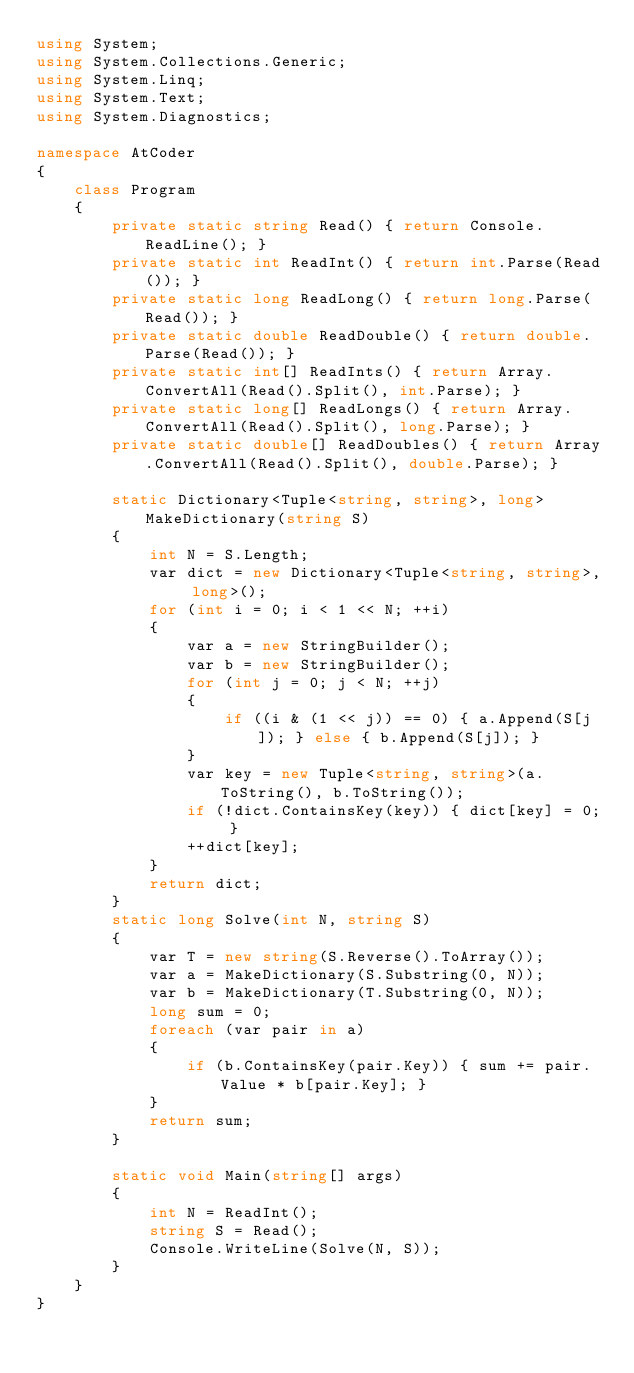Convert code to text. <code><loc_0><loc_0><loc_500><loc_500><_C#_>using System;
using System.Collections.Generic;
using System.Linq;
using System.Text;
using System.Diagnostics;

namespace AtCoder
{
    class Program
    {
        private static string Read() { return Console.ReadLine(); }
        private static int ReadInt() { return int.Parse(Read()); }
        private static long ReadLong() { return long.Parse(Read()); }
        private static double ReadDouble() { return double.Parse(Read()); }
        private static int[] ReadInts() { return Array.ConvertAll(Read().Split(), int.Parse); }
        private static long[] ReadLongs() { return Array.ConvertAll(Read().Split(), long.Parse); }
        private static double[] ReadDoubles() { return Array.ConvertAll(Read().Split(), double.Parse); }

        static Dictionary<Tuple<string, string>, long> MakeDictionary(string S)
        {
            int N = S.Length;
            var dict = new Dictionary<Tuple<string, string>, long>();
            for (int i = 0; i < 1 << N; ++i)
            {
                var a = new StringBuilder();
                var b = new StringBuilder();
                for (int j = 0; j < N; ++j)
                {
                    if ((i & (1 << j)) == 0) { a.Append(S[j]); } else { b.Append(S[j]); }
                }
                var key = new Tuple<string, string>(a.ToString(), b.ToString());
                if (!dict.ContainsKey(key)) { dict[key] = 0; }
                ++dict[key];
            }
            return dict;
        }
        static long Solve(int N, string S)
        {
            var T = new string(S.Reverse().ToArray());
            var a = MakeDictionary(S.Substring(0, N));
            var b = MakeDictionary(T.Substring(0, N));
            long sum = 0;
            foreach (var pair in a)
            {
                if (b.ContainsKey(pair.Key)) { sum += pair.Value * b[pair.Key]; }
            }
            return sum;
        }

        static void Main(string[] args)
        {
            int N = ReadInt();
            string S = Read();
            Console.WriteLine(Solve(N, S));
        }
    }
}
</code> 